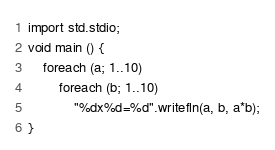<code> <loc_0><loc_0><loc_500><loc_500><_D_>import std.stdio;
void main () {
	foreach (a; 1..10)
		foreach (b; 1..10)
			"%dx%d=%d".writefln(a, b, a*b);
}</code> 